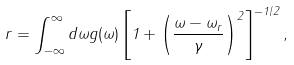<formula> <loc_0><loc_0><loc_500><loc_500>r = \int _ { - \infty } ^ { \infty } d \omega g ( \omega ) \left [ 1 + \left ( \frac { \omega - \omega _ { r } } { \gamma } \right ) ^ { 2 } \right ] ^ { - 1 / 2 } ,</formula> 